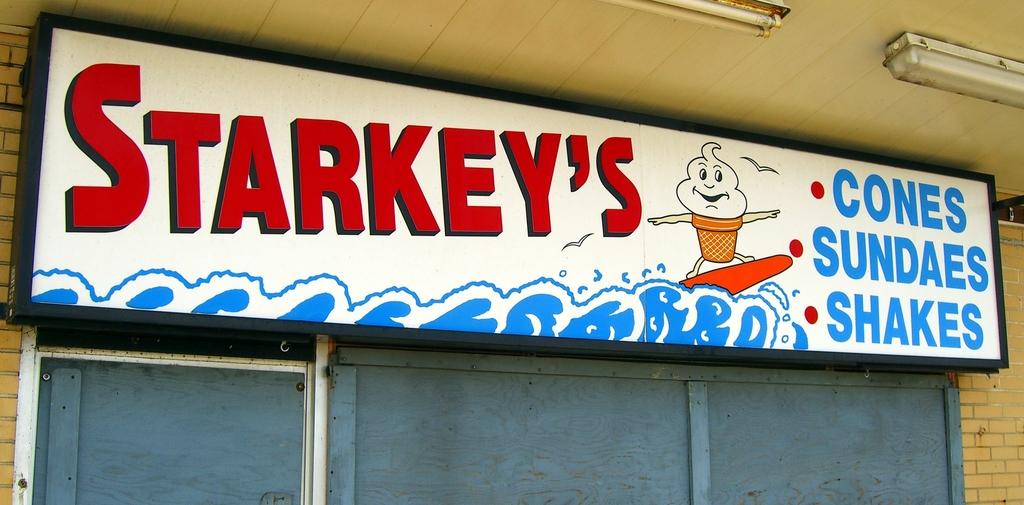What kind of food does this store sell?
Ensure brevity in your answer.  Cones, sundaes, shakes. What is sold at starkey's?
Your answer should be very brief. Cones, sundaes, shakes. 